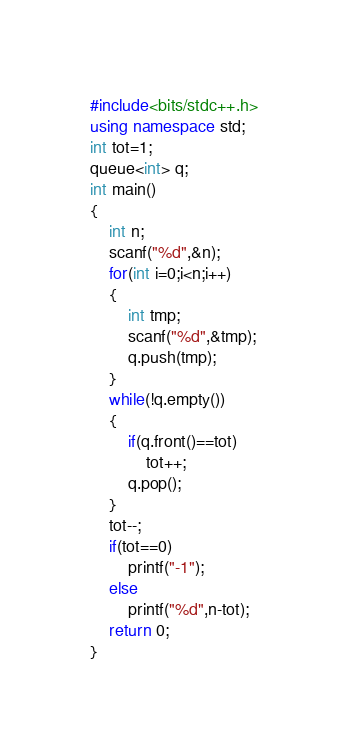<code> <loc_0><loc_0><loc_500><loc_500><_C++_>#include<bits/stdc++.h>
using namespace std;
int tot=1;
queue<int> q;
int main()
{
	int n;
	scanf("%d",&n);
	for(int i=0;i<n;i++)
	{
		int tmp;
		scanf("%d",&tmp);
		q.push(tmp);
	}
	while(!q.empty())
	{
		if(q.front()==tot)
			tot++;
		q.pop();
	}
	tot--;
	if(tot==0)
		printf("-1");
	else
		printf("%d",n-tot);
	return 0;
}</code> 